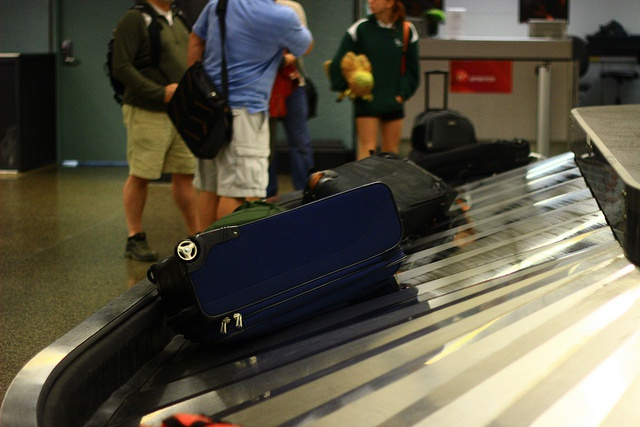Describe the objects in this image and their specific colors. I can see suitcase in black, gray, darkgreen, and khaki tones, people in black, gray, and darkblue tones, people in black, olive, and maroon tones, people in black, maroon, brown, and olive tones, and backpack in black, navy, maroon, and gray tones in this image. 